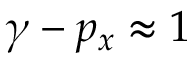Convert formula to latex. <formula><loc_0><loc_0><loc_500><loc_500>\gamma - p _ { x } \approx 1</formula> 